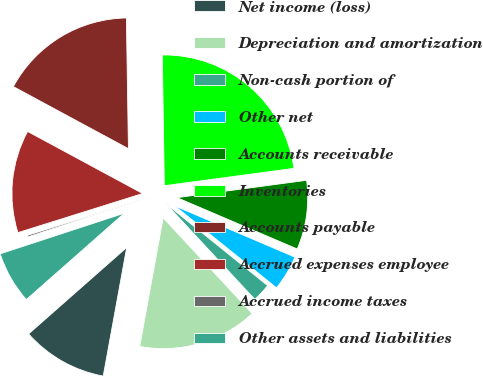Convert chart to OTSL. <chart><loc_0><loc_0><loc_500><loc_500><pie_chart><fcel>Net income (loss)<fcel>Depreciation and amortization<fcel>Non-cash portion of<fcel>Other net<fcel>Accounts receivable<fcel>Inventories<fcel>Accounts payable<fcel>Accrued expenses employee<fcel>Accrued income taxes<fcel>Other assets and liabilities<nl><fcel>10.63%<fcel>14.79%<fcel>2.29%<fcel>4.37%<fcel>8.54%<fcel>23.13%<fcel>16.88%<fcel>12.71%<fcel>0.2%<fcel>6.46%<nl></chart> 